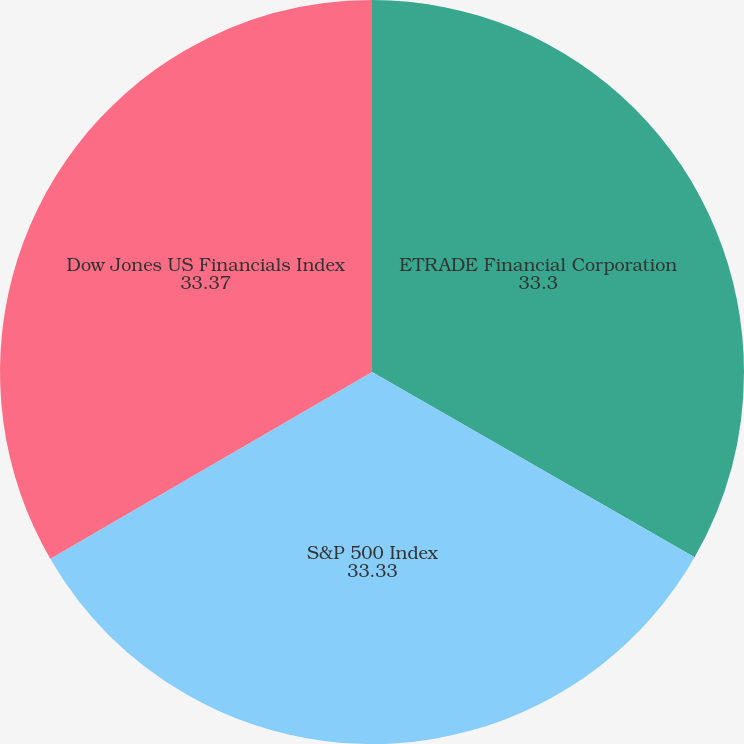Convert chart to OTSL. <chart><loc_0><loc_0><loc_500><loc_500><pie_chart><fcel>ETRADE Financial Corporation<fcel>S&P 500 Index<fcel>Dow Jones US Financials Index<nl><fcel>33.3%<fcel>33.33%<fcel>33.37%<nl></chart> 